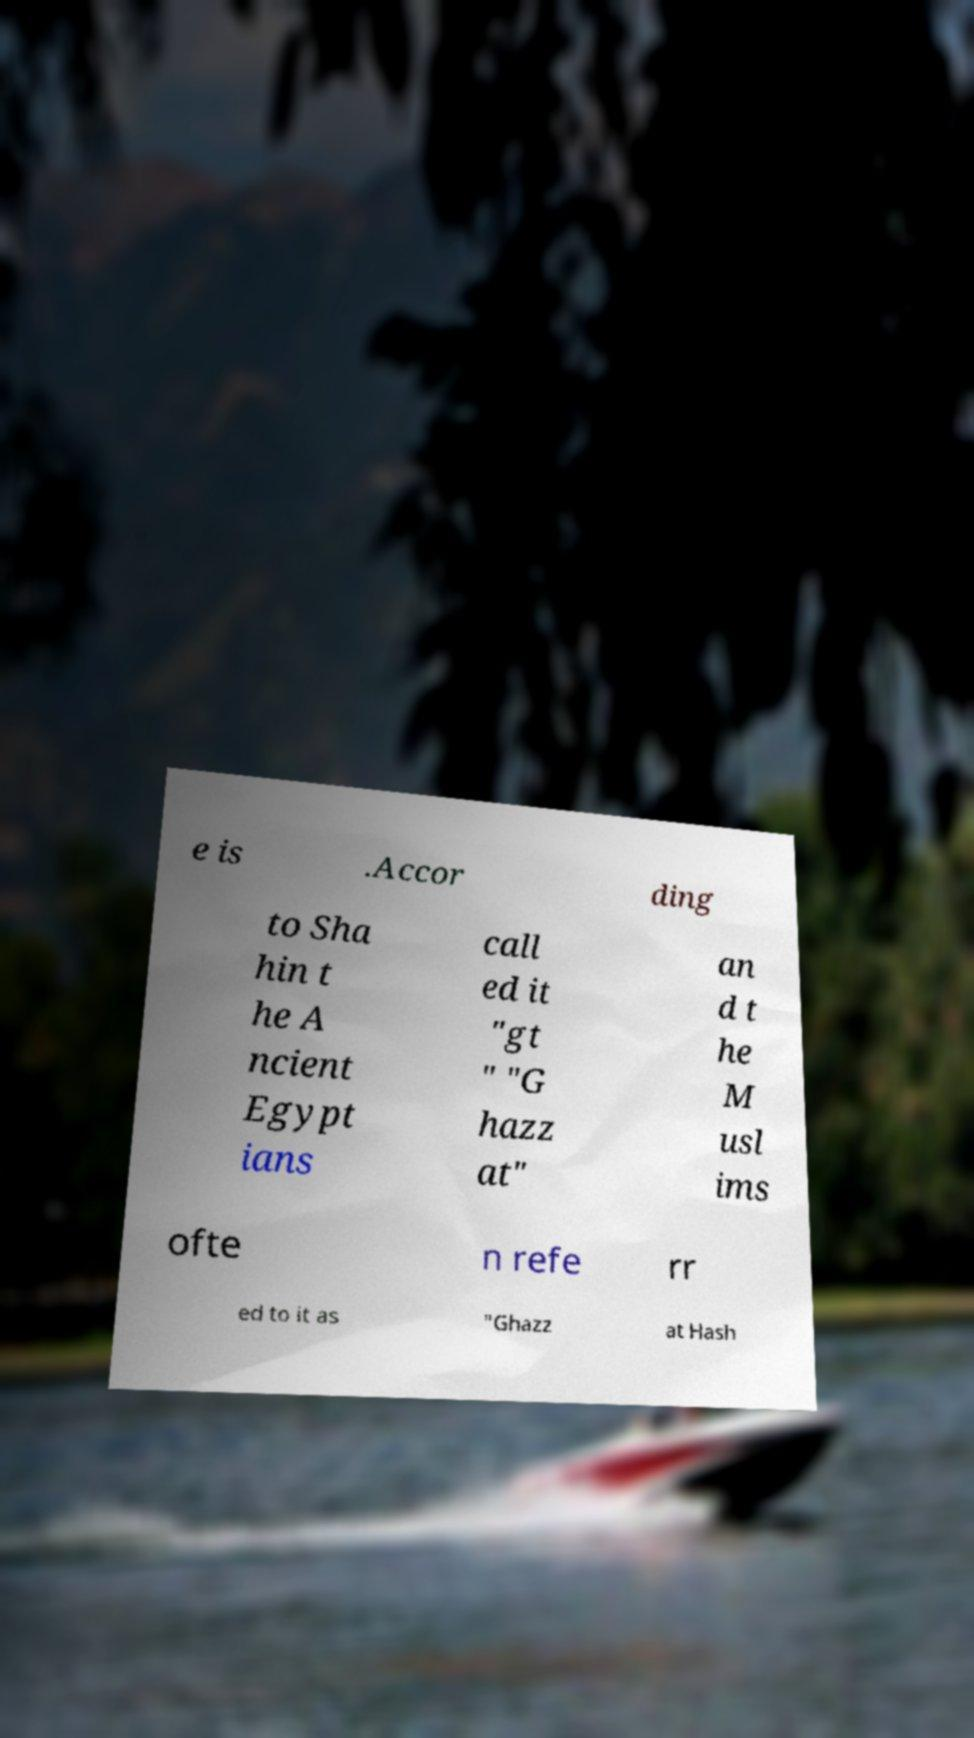What messages or text are displayed in this image? I need them in a readable, typed format. e is .Accor ding to Sha hin t he A ncient Egypt ians call ed it "gt " "G hazz at" an d t he M usl ims ofte n refe rr ed to it as "Ghazz at Hash 